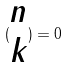<formula> <loc_0><loc_0><loc_500><loc_500>( \begin{matrix} n \\ k \end{matrix} ) = 0</formula> 